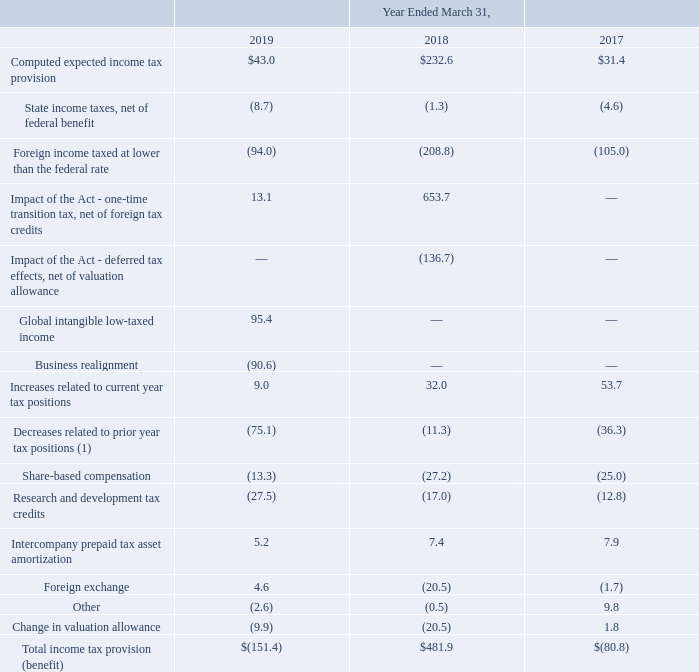The provision for income taxes differs from the amount computed by applying the statutory federal tax rate to income before income taxes. The sources and tax effects of the differences in the total income tax provision are as follows (amounts in millions):
(1) The release of prior year tax positions during fiscal 2019 increased the basic and diluted net income per common share by $0.32 and $0.30, respectively. The release of prior year tax positions during fiscal 2018 increased the basic and diluted net income per common share by $0.05. The release of prior year tax positions during fiscal 2017 increased the basic and diluted net income per common share by $0.17 and $0.15, respectively.
The foreign tax rate differential benefit primarily relates to the Company's operations in Thailand, Malta and Ireland. The Company's Thailand manufacturing operations are currently subject to numerous tax holidays granted to the Company based on its investment in property, plant and equipment in Thailand. The Company's tax holiday periods in Thailand expire between fiscal 2022 and 2026, however, the Company actively seeks to obtain new tax holidays. The Company does not expect the future expiration of any of its tax holiday periods in Thailand to have a material impact on its effective tax rate. The Company’s Microsemi operations in Malaysia are subject to a tax holiday that effectively reduces the income tax rate in that jurisdiction. Microsemi’s tax holiday in Malaysia was granted in 2009 and is effective through December 2019, subject to continued compliance with the tax holiday’s requirements. The aggregate dollar expense derived from these tax holidays approximated $0.1 million in fiscal 2019. The aggregate dollar benefit derived from these tax holidays approximated $6.2 million and $13.2 million in fiscal 2018 and 2017, respectively. The impact of the tax holidays during fiscal 2019 did not impact basic and diluted net income per common share. The impact of the tax holidays during fiscal 2018 increased the basic and diluted net income per common share by $0.03 and $0.02, respectively. The impact of the tax holidays during fiscal 2017 increased the basic and diluted net income per common share by $0.06.
What does the foreign tax rate differential benefit primarily relate to? The company's operations in thailand, malta and ireland. What was the State income taxes, net of federal benefit in 2019?
Answer scale should be: million. (8.7). Which years does the table provide information for The sources and tax effects of the differences in the total income tax provision? 2019, 2018, 2017. How many years did Intercompany prepaid tax asset amortization exceed $7 million? 2018##2017
Answer: 2. What was the change in the Computed expected income tax provision between 2017 and 2018?
Answer scale should be: million. 232.6-31.4
Answer: 201.2. What was the percentage change in the Total income tax provision (benefit) between 2018 and 2019?
Answer scale should be: percent. (-151.4-481.9)/481.9
Answer: -131.42. 